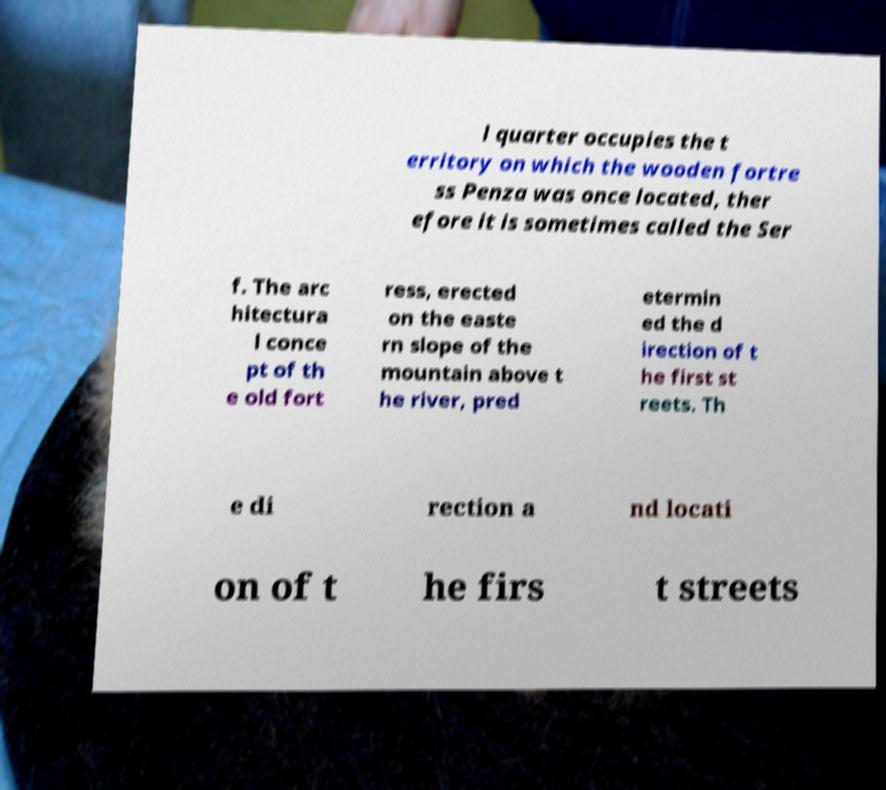I need the written content from this picture converted into text. Can you do that? l quarter occupies the t erritory on which the wooden fortre ss Penza was once located, ther efore it is sometimes called the Ser f. The arc hitectura l conce pt of th e old fort ress, erected on the easte rn slope of the mountain above t he river, pred etermin ed the d irection of t he first st reets. Th e di rection a nd locati on of t he firs t streets 